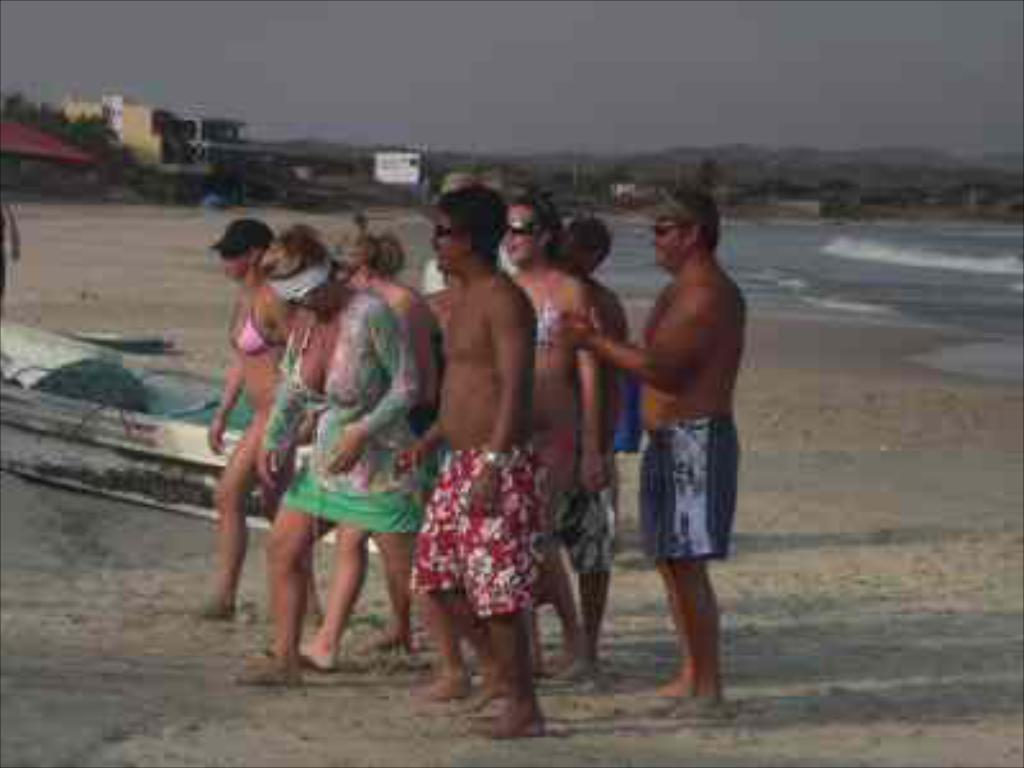What is the overall quality of the image? The image is blurred. Can you identify any living beings in the image? Yes, there are people in the image. What else can be seen in the image besides people? There are objects, sand, water, buildings, and the sky visible in the image. How does the goat stop in the image? There is no goat present in the image, so it cannot stop or perform any actions. 